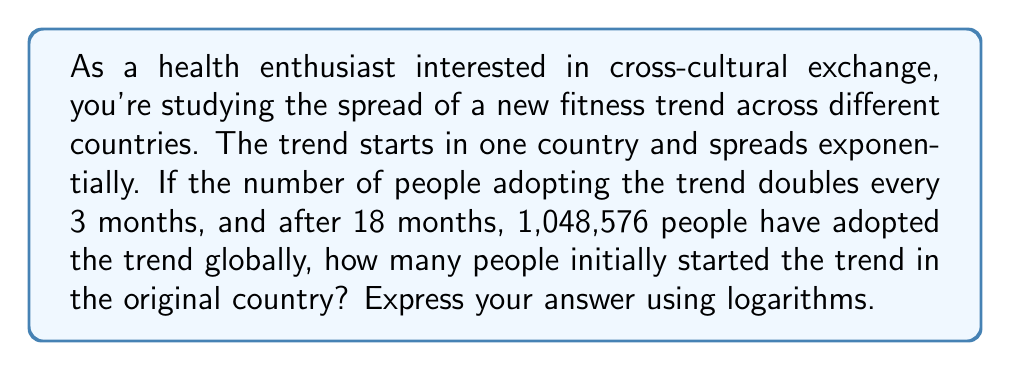Show me your answer to this math problem. Let's approach this step-by-step using logarithms:

1) Let $x$ be the initial number of people who started the trend.

2) The trend doubles every 3 months, and we're looking at an 18-month period. This means the trend has doubled 6 times (18 ÷ 3 = 6).

3) We can express this mathematically as:

   $x \cdot 2^6 = 1,048,576$

4) To solve for $x$, we can use logarithms. Let's apply $\log_2$ to both sides:

   $\log_2(x \cdot 2^6) = \log_2(1,048,576)$

5) Using the logarithm product rule:

   $\log_2(x) + \log_2(2^6) = \log_2(1,048,576)$

6) Simplify $\log_2(2^6)$:

   $\log_2(x) + 6 = \log_2(1,048,576)$

7) Now, let's calculate $\log_2(1,048,576)$:

   $1,048,576 = 2^{20}$, so $\log_2(1,048,576) = 20$

8) Our equation becomes:

   $\log_2(x) + 6 = 20$

9) Solve for $\log_2(x)$:

   $\log_2(x) = 20 - 6 = 14$

10) To find $x$, we need to apply $2^{14}$ to both sides:

    $x = 2^{14} = 16,384$

Therefore, 16,384 people initially started the trend in the original country.
Answer: $x = 2^{14} = 16,384$ 